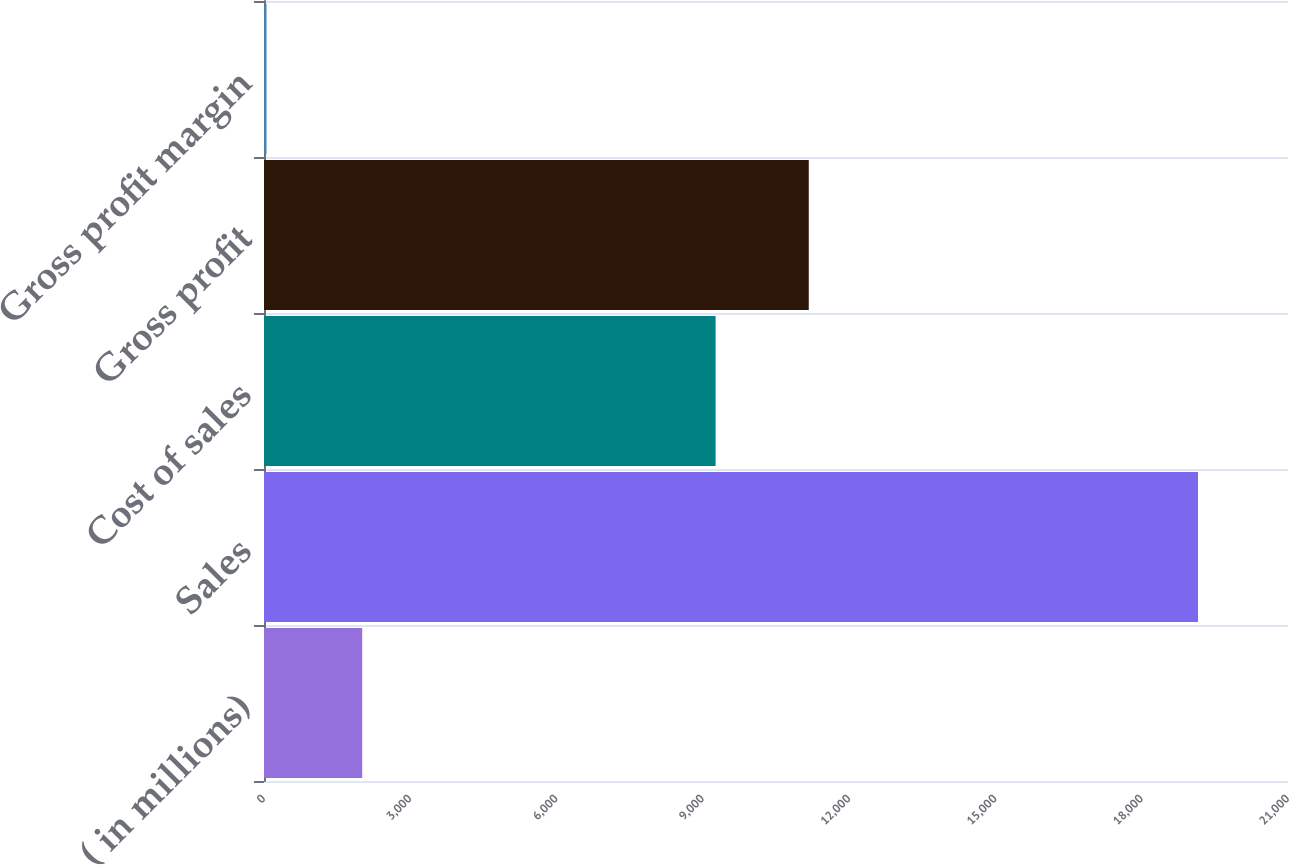Convert chart to OTSL. <chart><loc_0><loc_0><loc_500><loc_500><bar_chart><fcel>( in millions)<fcel>Sales<fcel>Cost of sales<fcel>Gross profit<fcel>Gross profit margin<nl><fcel>2014<fcel>19154<fcel>9261.4<fcel>11171.6<fcel>51.6<nl></chart> 